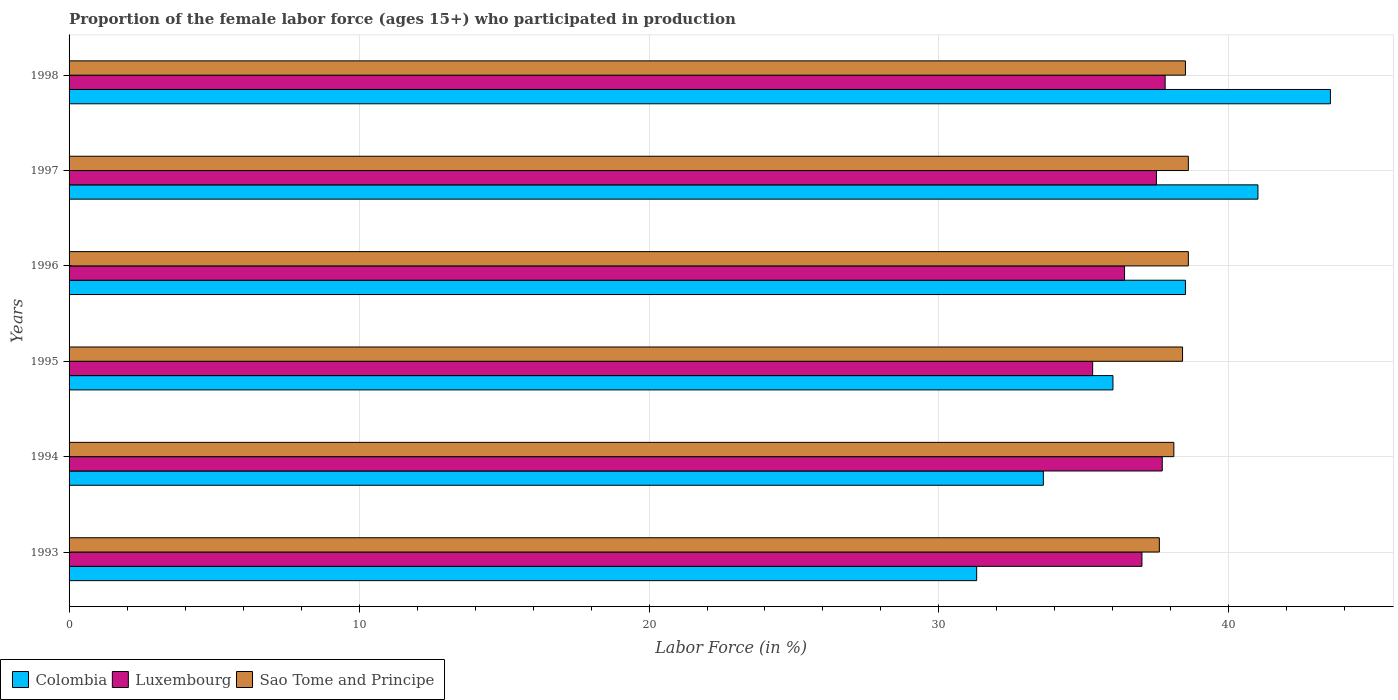How many groups of bars are there?
Offer a terse response. 6. How many bars are there on the 6th tick from the bottom?
Give a very brief answer. 3. What is the proportion of the female labor force who participated in production in Sao Tome and Principe in 1997?
Make the answer very short. 38.6. Across all years, what is the maximum proportion of the female labor force who participated in production in Luxembourg?
Offer a very short reply. 37.8. Across all years, what is the minimum proportion of the female labor force who participated in production in Colombia?
Your answer should be compact. 31.3. In which year was the proportion of the female labor force who participated in production in Colombia minimum?
Your response must be concise. 1993. What is the total proportion of the female labor force who participated in production in Sao Tome and Principe in the graph?
Provide a succinct answer. 229.8. What is the difference between the proportion of the female labor force who participated in production in Sao Tome and Principe in 1993 and that in 1996?
Provide a succinct answer. -1. What is the difference between the proportion of the female labor force who participated in production in Luxembourg in 1993 and the proportion of the female labor force who participated in production in Colombia in 1998?
Your response must be concise. -6.5. What is the average proportion of the female labor force who participated in production in Colombia per year?
Your response must be concise. 37.32. In the year 1998, what is the difference between the proportion of the female labor force who participated in production in Luxembourg and proportion of the female labor force who participated in production in Sao Tome and Principe?
Keep it short and to the point. -0.7. What is the ratio of the proportion of the female labor force who participated in production in Luxembourg in 1996 to that in 1997?
Offer a very short reply. 0.97. What is the difference between the highest and the lowest proportion of the female labor force who participated in production in Colombia?
Make the answer very short. 12.2. In how many years, is the proportion of the female labor force who participated in production in Colombia greater than the average proportion of the female labor force who participated in production in Colombia taken over all years?
Keep it short and to the point. 3. What does the 3rd bar from the top in 1996 represents?
Your response must be concise. Colombia. What does the 2nd bar from the bottom in 1997 represents?
Provide a succinct answer. Luxembourg. What is the difference between two consecutive major ticks on the X-axis?
Give a very brief answer. 10. Does the graph contain any zero values?
Your response must be concise. No. Does the graph contain grids?
Make the answer very short. Yes. How many legend labels are there?
Provide a succinct answer. 3. What is the title of the graph?
Keep it short and to the point. Proportion of the female labor force (ages 15+) who participated in production. Does "Netherlands" appear as one of the legend labels in the graph?
Provide a short and direct response. No. What is the label or title of the X-axis?
Your response must be concise. Labor Force (in %). What is the Labor Force (in %) in Colombia in 1993?
Your response must be concise. 31.3. What is the Labor Force (in %) in Luxembourg in 1993?
Ensure brevity in your answer.  37. What is the Labor Force (in %) in Sao Tome and Principe in 1993?
Offer a terse response. 37.6. What is the Labor Force (in %) in Colombia in 1994?
Offer a terse response. 33.6. What is the Labor Force (in %) in Luxembourg in 1994?
Your answer should be very brief. 37.7. What is the Labor Force (in %) in Sao Tome and Principe in 1994?
Make the answer very short. 38.1. What is the Labor Force (in %) of Luxembourg in 1995?
Your answer should be very brief. 35.3. What is the Labor Force (in %) of Sao Tome and Principe in 1995?
Your response must be concise. 38.4. What is the Labor Force (in %) in Colombia in 1996?
Provide a short and direct response. 38.5. What is the Labor Force (in %) in Luxembourg in 1996?
Your answer should be compact. 36.4. What is the Labor Force (in %) in Sao Tome and Principe in 1996?
Keep it short and to the point. 38.6. What is the Labor Force (in %) of Luxembourg in 1997?
Keep it short and to the point. 37.5. What is the Labor Force (in %) of Sao Tome and Principe in 1997?
Provide a succinct answer. 38.6. What is the Labor Force (in %) in Colombia in 1998?
Offer a terse response. 43.5. What is the Labor Force (in %) of Luxembourg in 1998?
Your response must be concise. 37.8. What is the Labor Force (in %) of Sao Tome and Principe in 1998?
Offer a very short reply. 38.5. Across all years, what is the maximum Labor Force (in %) of Colombia?
Provide a short and direct response. 43.5. Across all years, what is the maximum Labor Force (in %) in Luxembourg?
Your answer should be compact. 37.8. Across all years, what is the maximum Labor Force (in %) of Sao Tome and Principe?
Your answer should be compact. 38.6. Across all years, what is the minimum Labor Force (in %) in Colombia?
Offer a very short reply. 31.3. Across all years, what is the minimum Labor Force (in %) in Luxembourg?
Provide a short and direct response. 35.3. Across all years, what is the minimum Labor Force (in %) in Sao Tome and Principe?
Offer a terse response. 37.6. What is the total Labor Force (in %) of Colombia in the graph?
Give a very brief answer. 223.9. What is the total Labor Force (in %) in Luxembourg in the graph?
Your response must be concise. 221.7. What is the total Labor Force (in %) in Sao Tome and Principe in the graph?
Your answer should be compact. 229.8. What is the difference between the Labor Force (in %) of Colombia in 1993 and that in 1994?
Your answer should be very brief. -2.3. What is the difference between the Labor Force (in %) in Sao Tome and Principe in 1993 and that in 1994?
Offer a terse response. -0.5. What is the difference between the Labor Force (in %) of Sao Tome and Principe in 1993 and that in 1995?
Make the answer very short. -0.8. What is the difference between the Labor Force (in %) in Luxembourg in 1993 and that in 1996?
Ensure brevity in your answer.  0.6. What is the difference between the Labor Force (in %) in Sao Tome and Principe in 1993 and that in 1997?
Make the answer very short. -1. What is the difference between the Labor Force (in %) in Colombia in 1994 and that in 1995?
Your response must be concise. -2.4. What is the difference between the Labor Force (in %) in Luxembourg in 1994 and that in 1995?
Provide a succinct answer. 2.4. What is the difference between the Labor Force (in %) of Sao Tome and Principe in 1994 and that in 1995?
Keep it short and to the point. -0.3. What is the difference between the Labor Force (in %) of Sao Tome and Principe in 1994 and that in 1996?
Provide a succinct answer. -0.5. What is the difference between the Labor Force (in %) of Colombia in 1994 and that in 1997?
Your response must be concise. -7.4. What is the difference between the Labor Force (in %) of Sao Tome and Principe in 1994 and that in 1997?
Give a very brief answer. -0.5. What is the difference between the Labor Force (in %) of Colombia in 1994 and that in 1998?
Offer a terse response. -9.9. What is the difference between the Labor Force (in %) in Luxembourg in 1994 and that in 1998?
Your response must be concise. -0.1. What is the difference between the Labor Force (in %) of Colombia in 1995 and that in 1996?
Your answer should be compact. -2.5. What is the difference between the Labor Force (in %) in Sao Tome and Principe in 1995 and that in 1997?
Offer a terse response. -0.2. What is the difference between the Labor Force (in %) in Colombia in 1996 and that in 1997?
Offer a terse response. -2.5. What is the difference between the Labor Force (in %) of Luxembourg in 1996 and that in 1997?
Keep it short and to the point. -1.1. What is the difference between the Labor Force (in %) in Colombia in 1996 and that in 1998?
Provide a succinct answer. -5. What is the difference between the Labor Force (in %) of Luxembourg in 1996 and that in 1998?
Offer a very short reply. -1.4. What is the difference between the Labor Force (in %) in Colombia in 1993 and the Labor Force (in %) in Luxembourg in 1994?
Provide a succinct answer. -6.4. What is the difference between the Labor Force (in %) in Luxembourg in 1993 and the Labor Force (in %) in Sao Tome and Principe in 1994?
Offer a terse response. -1.1. What is the difference between the Labor Force (in %) in Colombia in 1993 and the Labor Force (in %) in Sao Tome and Principe in 1995?
Keep it short and to the point. -7.1. What is the difference between the Labor Force (in %) in Luxembourg in 1993 and the Labor Force (in %) in Sao Tome and Principe in 1995?
Your response must be concise. -1.4. What is the difference between the Labor Force (in %) in Colombia in 1993 and the Labor Force (in %) in Luxembourg in 1997?
Provide a succinct answer. -6.2. What is the difference between the Labor Force (in %) in Colombia in 1993 and the Labor Force (in %) in Luxembourg in 1998?
Your answer should be very brief. -6.5. What is the difference between the Labor Force (in %) in Luxembourg in 1993 and the Labor Force (in %) in Sao Tome and Principe in 1998?
Your answer should be compact. -1.5. What is the difference between the Labor Force (in %) in Colombia in 1994 and the Labor Force (in %) in Luxembourg in 1995?
Your response must be concise. -1.7. What is the difference between the Labor Force (in %) in Luxembourg in 1994 and the Labor Force (in %) in Sao Tome and Principe in 1995?
Offer a terse response. -0.7. What is the difference between the Labor Force (in %) of Colombia in 1994 and the Labor Force (in %) of Sao Tome and Principe in 1996?
Give a very brief answer. -5. What is the difference between the Labor Force (in %) in Colombia in 1994 and the Labor Force (in %) in Luxembourg in 1997?
Provide a short and direct response. -3.9. What is the difference between the Labor Force (in %) of Colombia in 1994 and the Labor Force (in %) of Sao Tome and Principe in 1997?
Offer a very short reply. -5. What is the difference between the Labor Force (in %) of Luxembourg in 1994 and the Labor Force (in %) of Sao Tome and Principe in 1997?
Give a very brief answer. -0.9. What is the difference between the Labor Force (in %) of Luxembourg in 1995 and the Labor Force (in %) of Sao Tome and Principe in 1996?
Make the answer very short. -3.3. What is the difference between the Labor Force (in %) of Colombia in 1995 and the Labor Force (in %) of Sao Tome and Principe in 1997?
Offer a terse response. -2.6. What is the difference between the Labor Force (in %) in Luxembourg in 1995 and the Labor Force (in %) in Sao Tome and Principe in 1997?
Provide a short and direct response. -3.3. What is the difference between the Labor Force (in %) of Colombia in 1995 and the Labor Force (in %) of Luxembourg in 1998?
Keep it short and to the point. -1.8. What is the difference between the Labor Force (in %) in Colombia in 1996 and the Labor Force (in %) in Sao Tome and Principe in 1998?
Keep it short and to the point. 0. What is the difference between the Labor Force (in %) of Luxembourg in 1996 and the Labor Force (in %) of Sao Tome and Principe in 1998?
Your response must be concise. -2.1. What is the average Labor Force (in %) of Colombia per year?
Offer a terse response. 37.32. What is the average Labor Force (in %) in Luxembourg per year?
Give a very brief answer. 36.95. What is the average Labor Force (in %) in Sao Tome and Principe per year?
Ensure brevity in your answer.  38.3. In the year 1993, what is the difference between the Labor Force (in %) of Luxembourg and Labor Force (in %) of Sao Tome and Principe?
Ensure brevity in your answer.  -0.6. In the year 1994, what is the difference between the Labor Force (in %) in Colombia and Labor Force (in %) in Luxembourg?
Your answer should be very brief. -4.1. In the year 1996, what is the difference between the Labor Force (in %) in Colombia and Labor Force (in %) in Sao Tome and Principe?
Ensure brevity in your answer.  -0.1. In the year 1997, what is the difference between the Labor Force (in %) in Colombia and Labor Force (in %) in Luxembourg?
Give a very brief answer. 3.5. In the year 1997, what is the difference between the Labor Force (in %) in Colombia and Labor Force (in %) in Sao Tome and Principe?
Make the answer very short. 2.4. In the year 1997, what is the difference between the Labor Force (in %) in Luxembourg and Labor Force (in %) in Sao Tome and Principe?
Keep it short and to the point. -1.1. In the year 1998, what is the difference between the Labor Force (in %) of Colombia and Labor Force (in %) of Luxembourg?
Give a very brief answer. 5.7. In the year 1998, what is the difference between the Labor Force (in %) in Luxembourg and Labor Force (in %) in Sao Tome and Principe?
Make the answer very short. -0.7. What is the ratio of the Labor Force (in %) in Colombia in 1993 to that in 1994?
Provide a short and direct response. 0.93. What is the ratio of the Labor Force (in %) of Luxembourg in 1993 to that in 1994?
Keep it short and to the point. 0.98. What is the ratio of the Labor Force (in %) in Sao Tome and Principe in 1993 to that in 1994?
Keep it short and to the point. 0.99. What is the ratio of the Labor Force (in %) in Colombia in 1993 to that in 1995?
Your answer should be very brief. 0.87. What is the ratio of the Labor Force (in %) in Luxembourg in 1993 to that in 1995?
Give a very brief answer. 1.05. What is the ratio of the Labor Force (in %) of Sao Tome and Principe in 1993 to that in 1995?
Make the answer very short. 0.98. What is the ratio of the Labor Force (in %) of Colombia in 1993 to that in 1996?
Keep it short and to the point. 0.81. What is the ratio of the Labor Force (in %) in Luxembourg in 1993 to that in 1996?
Ensure brevity in your answer.  1.02. What is the ratio of the Labor Force (in %) of Sao Tome and Principe in 1993 to that in 1996?
Ensure brevity in your answer.  0.97. What is the ratio of the Labor Force (in %) of Colombia in 1993 to that in 1997?
Provide a succinct answer. 0.76. What is the ratio of the Labor Force (in %) in Luxembourg in 1993 to that in 1997?
Offer a terse response. 0.99. What is the ratio of the Labor Force (in %) of Sao Tome and Principe in 1993 to that in 1997?
Your answer should be very brief. 0.97. What is the ratio of the Labor Force (in %) in Colombia in 1993 to that in 1998?
Ensure brevity in your answer.  0.72. What is the ratio of the Labor Force (in %) in Luxembourg in 1993 to that in 1998?
Offer a terse response. 0.98. What is the ratio of the Labor Force (in %) of Sao Tome and Principe in 1993 to that in 1998?
Give a very brief answer. 0.98. What is the ratio of the Labor Force (in %) of Luxembourg in 1994 to that in 1995?
Offer a very short reply. 1.07. What is the ratio of the Labor Force (in %) of Sao Tome and Principe in 1994 to that in 1995?
Keep it short and to the point. 0.99. What is the ratio of the Labor Force (in %) in Colombia in 1994 to that in 1996?
Your answer should be compact. 0.87. What is the ratio of the Labor Force (in %) in Luxembourg in 1994 to that in 1996?
Keep it short and to the point. 1.04. What is the ratio of the Labor Force (in %) of Sao Tome and Principe in 1994 to that in 1996?
Your answer should be very brief. 0.99. What is the ratio of the Labor Force (in %) of Colombia in 1994 to that in 1997?
Make the answer very short. 0.82. What is the ratio of the Labor Force (in %) of Sao Tome and Principe in 1994 to that in 1997?
Your answer should be compact. 0.99. What is the ratio of the Labor Force (in %) in Colombia in 1994 to that in 1998?
Make the answer very short. 0.77. What is the ratio of the Labor Force (in %) in Luxembourg in 1994 to that in 1998?
Ensure brevity in your answer.  1. What is the ratio of the Labor Force (in %) of Sao Tome and Principe in 1994 to that in 1998?
Keep it short and to the point. 0.99. What is the ratio of the Labor Force (in %) in Colombia in 1995 to that in 1996?
Keep it short and to the point. 0.94. What is the ratio of the Labor Force (in %) in Luxembourg in 1995 to that in 1996?
Provide a short and direct response. 0.97. What is the ratio of the Labor Force (in %) of Sao Tome and Principe in 1995 to that in 1996?
Your answer should be very brief. 0.99. What is the ratio of the Labor Force (in %) of Colombia in 1995 to that in 1997?
Your answer should be very brief. 0.88. What is the ratio of the Labor Force (in %) of Luxembourg in 1995 to that in 1997?
Your answer should be compact. 0.94. What is the ratio of the Labor Force (in %) of Sao Tome and Principe in 1995 to that in 1997?
Your response must be concise. 0.99. What is the ratio of the Labor Force (in %) in Colombia in 1995 to that in 1998?
Provide a short and direct response. 0.83. What is the ratio of the Labor Force (in %) of Luxembourg in 1995 to that in 1998?
Make the answer very short. 0.93. What is the ratio of the Labor Force (in %) of Sao Tome and Principe in 1995 to that in 1998?
Offer a terse response. 1. What is the ratio of the Labor Force (in %) of Colombia in 1996 to that in 1997?
Make the answer very short. 0.94. What is the ratio of the Labor Force (in %) of Luxembourg in 1996 to that in 1997?
Give a very brief answer. 0.97. What is the ratio of the Labor Force (in %) in Sao Tome and Principe in 1996 to that in 1997?
Make the answer very short. 1. What is the ratio of the Labor Force (in %) of Colombia in 1996 to that in 1998?
Your response must be concise. 0.89. What is the ratio of the Labor Force (in %) in Colombia in 1997 to that in 1998?
Give a very brief answer. 0.94. What is the ratio of the Labor Force (in %) of Luxembourg in 1997 to that in 1998?
Your answer should be compact. 0.99. What is the difference between the highest and the lowest Labor Force (in %) in Colombia?
Make the answer very short. 12.2. What is the difference between the highest and the lowest Labor Force (in %) in Luxembourg?
Offer a very short reply. 2.5. 